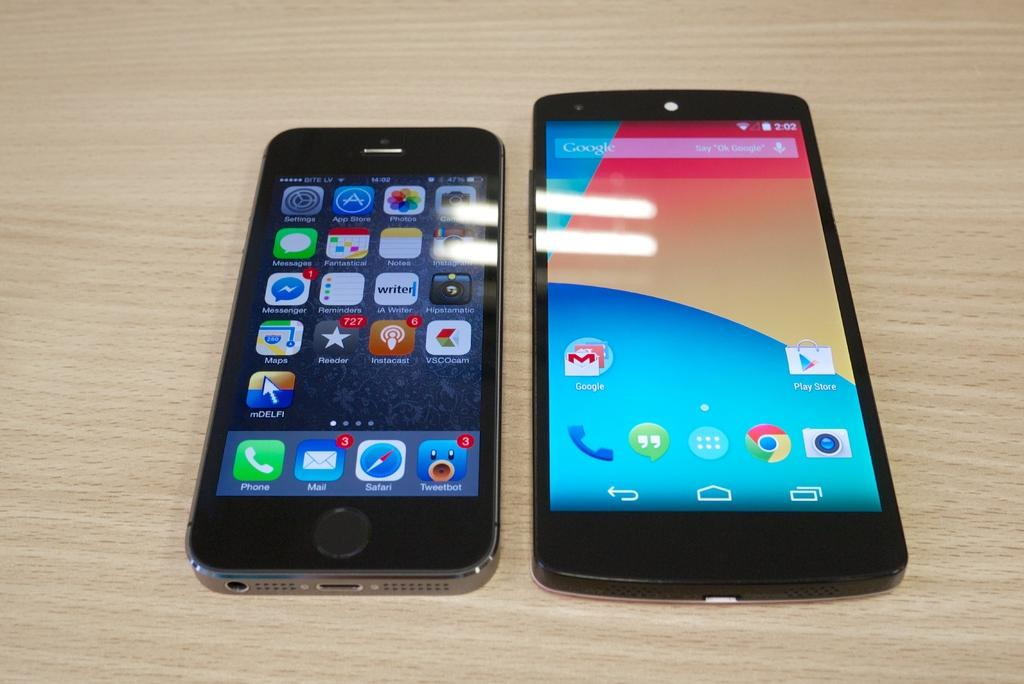<image>
Create a compact narrative representing the image presented. An iPhone and an Android phone are next to each other on a wooden table. 